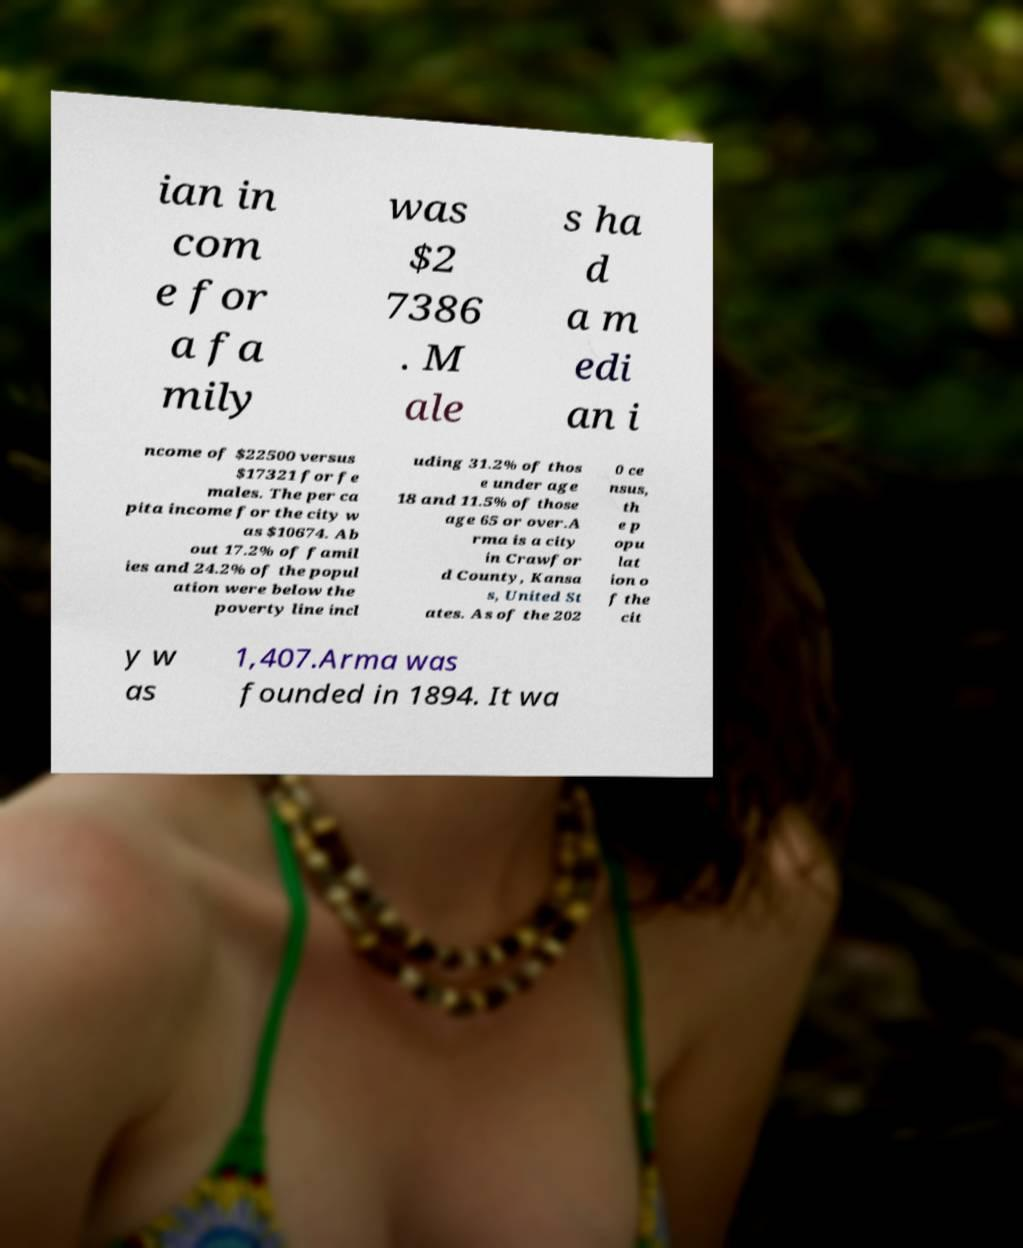Could you extract and type out the text from this image? ian in com e for a fa mily was $2 7386 . M ale s ha d a m edi an i ncome of $22500 versus $17321 for fe males. The per ca pita income for the city w as $10674. Ab out 17.2% of famil ies and 24.2% of the popul ation were below the poverty line incl uding 31.2% of thos e under age 18 and 11.5% of those age 65 or over.A rma is a city in Crawfor d County, Kansa s, United St ates. As of the 202 0 ce nsus, th e p opu lat ion o f the cit y w as 1,407.Arma was founded in 1894. It wa 